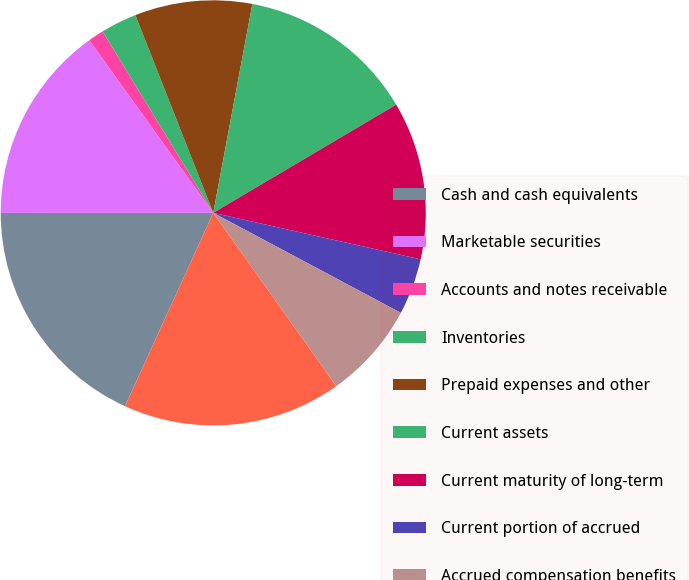<chart> <loc_0><loc_0><loc_500><loc_500><pie_chart><fcel>Cash and cash equivalents<fcel>Marketable securities<fcel>Accounts and notes receivable<fcel>Inventories<fcel>Prepaid expenses and other<fcel>Current assets<fcel>Current maturity of long-term<fcel>Current portion of accrued<fcel>Accrued compensation benefits<fcel>Taxes payable (including taxes<nl><fcel>18.18%<fcel>15.09%<fcel>1.2%<fcel>2.74%<fcel>8.92%<fcel>13.55%<fcel>12.01%<fcel>4.29%<fcel>7.38%<fcel>16.64%<nl></chart> 